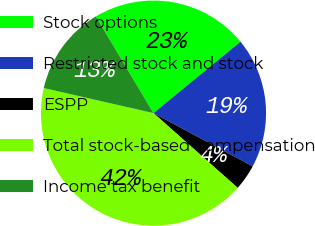<chart> <loc_0><loc_0><loc_500><loc_500><pie_chart><fcel>Stock options<fcel>Restricted stock and stock<fcel>ESPP<fcel>Total stock-based compensation<fcel>Income tax benefit<nl><fcel>22.61%<fcel>18.78%<fcel>3.72%<fcel>42.01%<fcel>12.88%<nl></chart> 